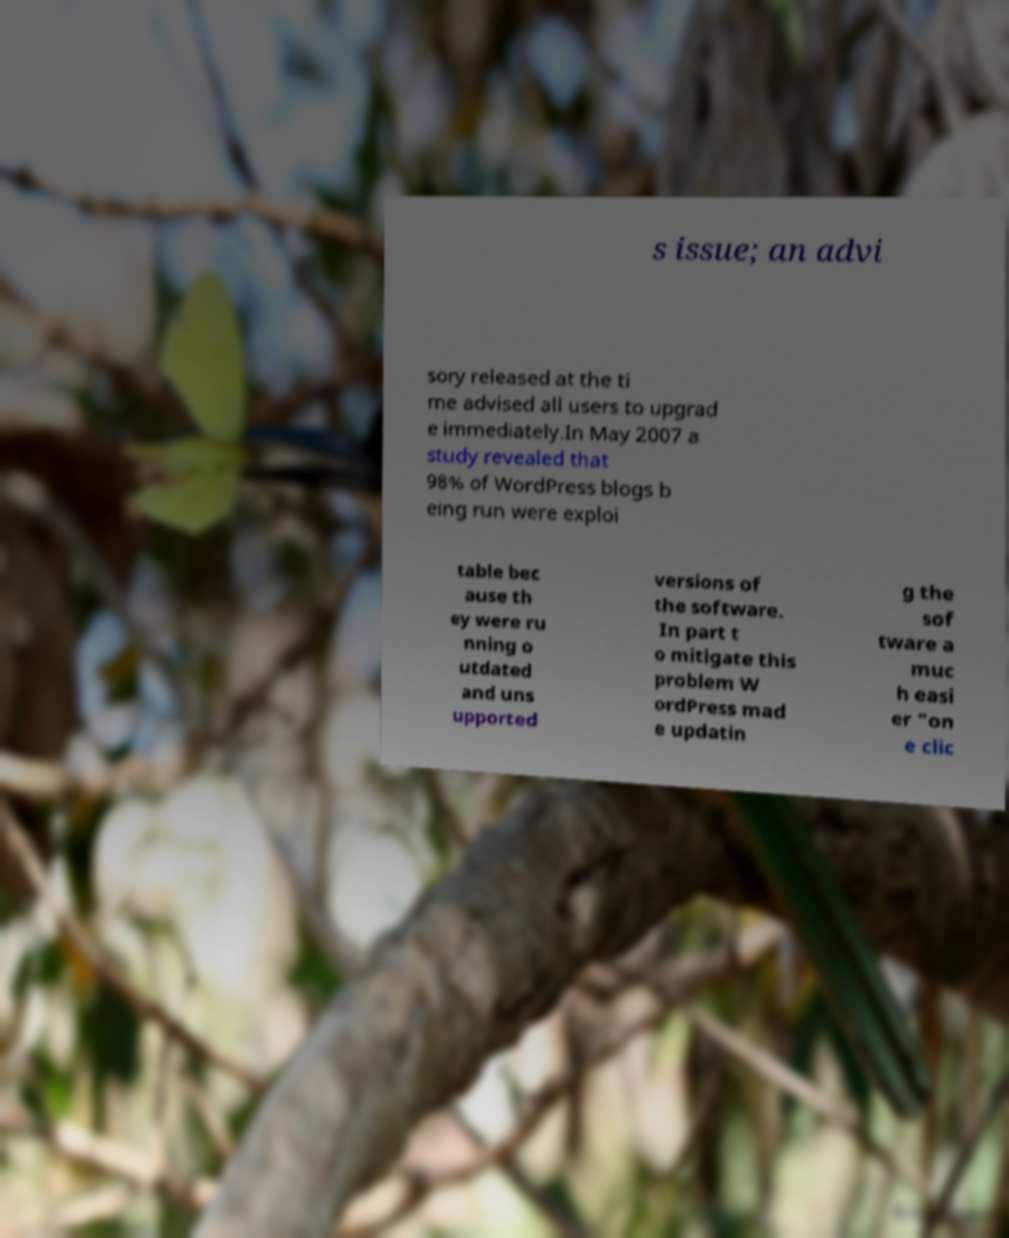Can you accurately transcribe the text from the provided image for me? s issue; an advi sory released at the ti me advised all users to upgrad e immediately.In May 2007 a study revealed that 98% of WordPress blogs b eing run were exploi table bec ause th ey were ru nning o utdated and uns upported versions of the software. In part t o mitigate this problem W ordPress mad e updatin g the sof tware a muc h easi er "on e clic 